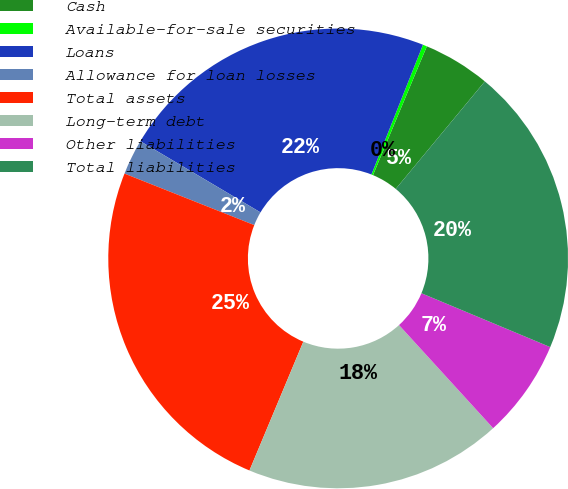Convert chart to OTSL. <chart><loc_0><loc_0><loc_500><loc_500><pie_chart><fcel>Cash<fcel>Available-for-sale securities<fcel>Loans<fcel>Allowance for loan losses<fcel>Total assets<fcel>Long-term debt<fcel>Other liabilities<fcel>Total liabilities<nl><fcel>4.71%<fcel>0.29%<fcel>22.5%<fcel>2.5%<fcel>24.71%<fcel>18.08%<fcel>6.92%<fcel>20.29%<nl></chart> 